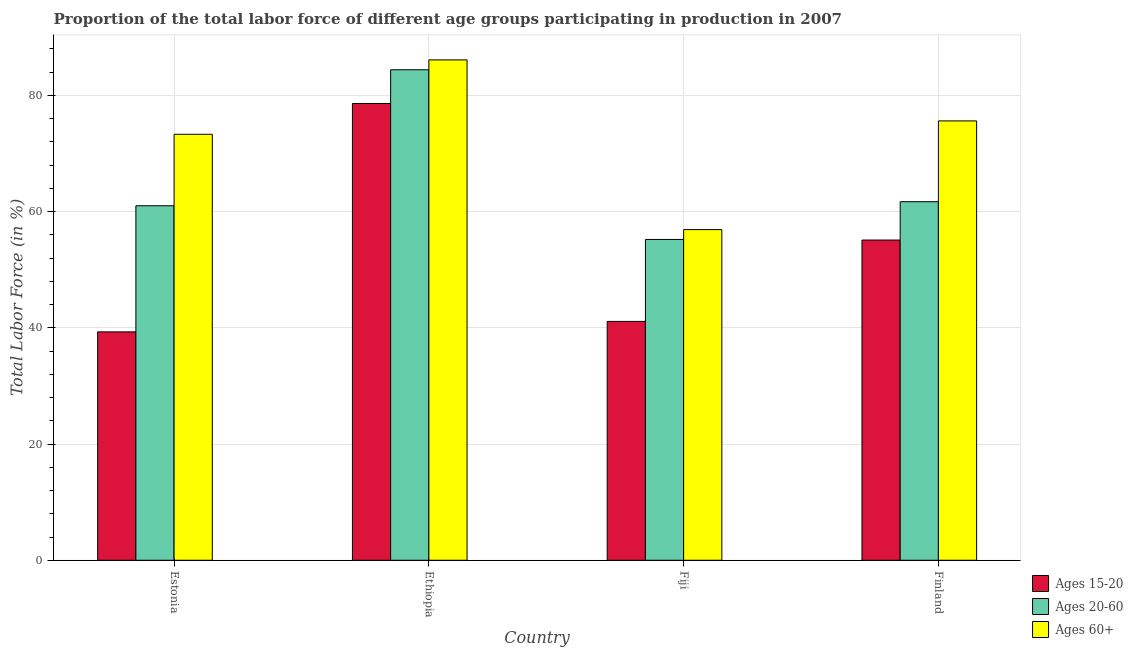How many different coloured bars are there?
Provide a succinct answer. 3. How many groups of bars are there?
Give a very brief answer. 4. Are the number of bars on each tick of the X-axis equal?
Give a very brief answer. Yes. How many bars are there on the 2nd tick from the left?
Provide a short and direct response. 3. What is the label of the 4th group of bars from the left?
Ensure brevity in your answer.  Finland. What is the percentage of labor force within the age group 20-60 in Finland?
Provide a succinct answer. 61.7. Across all countries, what is the maximum percentage of labor force within the age group 15-20?
Your answer should be very brief. 78.6. Across all countries, what is the minimum percentage of labor force above age 60?
Provide a short and direct response. 56.9. In which country was the percentage of labor force within the age group 15-20 maximum?
Provide a short and direct response. Ethiopia. In which country was the percentage of labor force within the age group 20-60 minimum?
Your answer should be very brief. Fiji. What is the total percentage of labor force within the age group 20-60 in the graph?
Your response must be concise. 262.3. What is the difference between the percentage of labor force within the age group 20-60 in Estonia and that in Finland?
Provide a succinct answer. -0.7. What is the difference between the percentage of labor force within the age group 15-20 in Fiji and the percentage of labor force within the age group 20-60 in Finland?
Your answer should be very brief. -20.6. What is the average percentage of labor force within the age group 20-60 per country?
Your response must be concise. 65.58. What is the difference between the percentage of labor force above age 60 and percentage of labor force within the age group 15-20 in Ethiopia?
Your response must be concise. 7.5. What is the ratio of the percentage of labor force within the age group 15-20 in Estonia to that in Ethiopia?
Your answer should be compact. 0.5. Is the percentage of labor force above age 60 in Ethiopia less than that in Finland?
Provide a short and direct response. No. Is the difference between the percentage of labor force within the age group 15-20 in Ethiopia and Finland greater than the difference between the percentage of labor force within the age group 20-60 in Ethiopia and Finland?
Your answer should be compact. Yes. What is the difference between the highest and the second highest percentage of labor force within the age group 20-60?
Ensure brevity in your answer.  22.7. What is the difference between the highest and the lowest percentage of labor force within the age group 20-60?
Your answer should be very brief. 29.2. In how many countries, is the percentage of labor force within the age group 20-60 greater than the average percentage of labor force within the age group 20-60 taken over all countries?
Keep it short and to the point. 1. Is the sum of the percentage of labor force within the age group 15-20 in Estonia and Finland greater than the maximum percentage of labor force above age 60 across all countries?
Offer a very short reply. Yes. What does the 1st bar from the left in Fiji represents?
Provide a short and direct response. Ages 15-20. What does the 2nd bar from the right in Fiji represents?
Your answer should be very brief. Ages 20-60. How many bars are there?
Ensure brevity in your answer.  12. What is the difference between two consecutive major ticks on the Y-axis?
Offer a very short reply. 20. Does the graph contain any zero values?
Keep it short and to the point. No. Where does the legend appear in the graph?
Provide a short and direct response. Bottom right. How many legend labels are there?
Offer a terse response. 3. What is the title of the graph?
Offer a very short reply. Proportion of the total labor force of different age groups participating in production in 2007. Does "Labor Tax" appear as one of the legend labels in the graph?
Offer a terse response. No. What is the label or title of the X-axis?
Provide a short and direct response. Country. What is the Total Labor Force (in %) in Ages 15-20 in Estonia?
Your answer should be very brief. 39.3. What is the Total Labor Force (in %) of Ages 20-60 in Estonia?
Provide a succinct answer. 61. What is the Total Labor Force (in %) of Ages 60+ in Estonia?
Offer a terse response. 73.3. What is the Total Labor Force (in %) in Ages 15-20 in Ethiopia?
Your response must be concise. 78.6. What is the Total Labor Force (in %) of Ages 20-60 in Ethiopia?
Offer a very short reply. 84.4. What is the Total Labor Force (in %) of Ages 60+ in Ethiopia?
Offer a terse response. 86.1. What is the Total Labor Force (in %) of Ages 15-20 in Fiji?
Provide a succinct answer. 41.1. What is the Total Labor Force (in %) in Ages 20-60 in Fiji?
Offer a terse response. 55.2. What is the Total Labor Force (in %) of Ages 60+ in Fiji?
Your answer should be compact. 56.9. What is the Total Labor Force (in %) in Ages 15-20 in Finland?
Ensure brevity in your answer.  55.1. What is the Total Labor Force (in %) in Ages 20-60 in Finland?
Make the answer very short. 61.7. What is the Total Labor Force (in %) of Ages 60+ in Finland?
Keep it short and to the point. 75.6. Across all countries, what is the maximum Total Labor Force (in %) of Ages 15-20?
Your answer should be very brief. 78.6. Across all countries, what is the maximum Total Labor Force (in %) in Ages 20-60?
Offer a very short reply. 84.4. Across all countries, what is the maximum Total Labor Force (in %) of Ages 60+?
Provide a succinct answer. 86.1. Across all countries, what is the minimum Total Labor Force (in %) in Ages 15-20?
Make the answer very short. 39.3. Across all countries, what is the minimum Total Labor Force (in %) in Ages 20-60?
Your answer should be compact. 55.2. Across all countries, what is the minimum Total Labor Force (in %) of Ages 60+?
Provide a short and direct response. 56.9. What is the total Total Labor Force (in %) of Ages 15-20 in the graph?
Provide a short and direct response. 214.1. What is the total Total Labor Force (in %) in Ages 20-60 in the graph?
Ensure brevity in your answer.  262.3. What is the total Total Labor Force (in %) of Ages 60+ in the graph?
Make the answer very short. 291.9. What is the difference between the Total Labor Force (in %) in Ages 15-20 in Estonia and that in Ethiopia?
Ensure brevity in your answer.  -39.3. What is the difference between the Total Labor Force (in %) in Ages 20-60 in Estonia and that in Ethiopia?
Your answer should be very brief. -23.4. What is the difference between the Total Labor Force (in %) in Ages 20-60 in Estonia and that in Fiji?
Give a very brief answer. 5.8. What is the difference between the Total Labor Force (in %) of Ages 60+ in Estonia and that in Fiji?
Offer a very short reply. 16.4. What is the difference between the Total Labor Force (in %) of Ages 15-20 in Estonia and that in Finland?
Provide a succinct answer. -15.8. What is the difference between the Total Labor Force (in %) in Ages 20-60 in Estonia and that in Finland?
Make the answer very short. -0.7. What is the difference between the Total Labor Force (in %) of Ages 60+ in Estonia and that in Finland?
Your answer should be compact. -2.3. What is the difference between the Total Labor Force (in %) of Ages 15-20 in Ethiopia and that in Fiji?
Provide a succinct answer. 37.5. What is the difference between the Total Labor Force (in %) in Ages 20-60 in Ethiopia and that in Fiji?
Ensure brevity in your answer.  29.2. What is the difference between the Total Labor Force (in %) of Ages 60+ in Ethiopia and that in Fiji?
Your answer should be compact. 29.2. What is the difference between the Total Labor Force (in %) in Ages 15-20 in Ethiopia and that in Finland?
Offer a terse response. 23.5. What is the difference between the Total Labor Force (in %) in Ages 20-60 in Ethiopia and that in Finland?
Provide a succinct answer. 22.7. What is the difference between the Total Labor Force (in %) in Ages 60+ in Ethiopia and that in Finland?
Your answer should be very brief. 10.5. What is the difference between the Total Labor Force (in %) of Ages 60+ in Fiji and that in Finland?
Ensure brevity in your answer.  -18.7. What is the difference between the Total Labor Force (in %) in Ages 15-20 in Estonia and the Total Labor Force (in %) in Ages 20-60 in Ethiopia?
Your answer should be very brief. -45.1. What is the difference between the Total Labor Force (in %) in Ages 15-20 in Estonia and the Total Labor Force (in %) in Ages 60+ in Ethiopia?
Your answer should be very brief. -46.8. What is the difference between the Total Labor Force (in %) of Ages 20-60 in Estonia and the Total Labor Force (in %) of Ages 60+ in Ethiopia?
Give a very brief answer. -25.1. What is the difference between the Total Labor Force (in %) in Ages 15-20 in Estonia and the Total Labor Force (in %) in Ages 20-60 in Fiji?
Ensure brevity in your answer.  -15.9. What is the difference between the Total Labor Force (in %) in Ages 15-20 in Estonia and the Total Labor Force (in %) in Ages 60+ in Fiji?
Offer a terse response. -17.6. What is the difference between the Total Labor Force (in %) in Ages 20-60 in Estonia and the Total Labor Force (in %) in Ages 60+ in Fiji?
Keep it short and to the point. 4.1. What is the difference between the Total Labor Force (in %) in Ages 15-20 in Estonia and the Total Labor Force (in %) in Ages 20-60 in Finland?
Provide a succinct answer. -22.4. What is the difference between the Total Labor Force (in %) of Ages 15-20 in Estonia and the Total Labor Force (in %) of Ages 60+ in Finland?
Offer a very short reply. -36.3. What is the difference between the Total Labor Force (in %) of Ages 20-60 in Estonia and the Total Labor Force (in %) of Ages 60+ in Finland?
Provide a succinct answer. -14.6. What is the difference between the Total Labor Force (in %) in Ages 15-20 in Ethiopia and the Total Labor Force (in %) in Ages 20-60 in Fiji?
Offer a terse response. 23.4. What is the difference between the Total Labor Force (in %) in Ages 15-20 in Ethiopia and the Total Labor Force (in %) in Ages 60+ in Fiji?
Give a very brief answer. 21.7. What is the difference between the Total Labor Force (in %) of Ages 15-20 in Ethiopia and the Total Labor Force (in %) of Ages 60+ in Finland?
Keep it short and to the point. 3. What is the difference between the Total Labor Force (in %) of Ages 20-60 in Ethiopia and the Total Labor Force (in %) of Ages 60+ in Finland?
Offer a very short reply. 8.8. What is the difference between the Total Labor Force (in %) of Ages 15-20 in Fiji and the Total Labor Force (in %) of Ages 20-60 in Finland?
Provide a short and direct response. -20.6. What is the difference between the Total Labor Force (in %) in Ages 15-20 in Fiji and the Total Labor Force (in %) in Ages 60+ in Finland?
Offer a terse response. -34.5. What is the difference between the Total Labor Force (in %) in Ages 20-60 in Fiji and the Total Labor Force (in %) in Ages 60+ in Finland?
Offer a terse response. -20.4. What is the average Total Labor Force (in %) in Ages 15-20 per country?
Provide a short and direct response. 53.52. What is the average Total Labor Force (in %) of Ages 20-60 per country?
Offer a terse response. 65.58. What is the average Total Labor Force (in %) in Ages 60+ per country?
Provide a short and direct response. 72.97. What is the difference between the Total Labor Force (in %) in Ages 15-20 and Total Labor Force (in %) in Ages 20-60 in Estonia?
Ensure brevity in your answer.  -21.7. What is the difference between the Total Labor Force (in %) in Ages 15-20 and Total Labor Force (in %) in Ages 60+ in Estonia?
Your answer should be compact. -34. What is the difference between the Total Labor Force (in %) of Ages 20-60 and Total Labor Force (in %) of Ages 60+ in Estonia?
Your answer should be compact. -12.3. What is the difference between the Total Labor Force (in %) in Ages 15-20 and Total Labor Force (in %) in Ages 60+ in Ethiopia?
Keep it short and to the point. -7.5. What is the difference between the Total Labor Force (in %) of Ages 15-20 and Total Labor Force (in %) of Ages 20-60 in Fiji?
Make the answer very short. -14.1. What is the difference between the Total Labor Force (in %) in Ages 15-20 and Total Labor Force (in %) in Ages 60+ in Fiji?
Your answer should be very brief. -15.8. What is the difference between the Total Labor Force (in %) in Ages 20-60 and Total Labor Force (in %) in Ages 60+ in Fiji?
Offer a terse response. -1.7. What is the difference between the Total Labor Force (in %) of Ages 15-20 and Total Labor Force (in %) of Ages 20-60 in Finland?
Make the answer very short. -6.6. What is the difference between the Total Labor Force (in %) in Ages 15-20 and Total Labor Force (in %) in Ages 60+ in Finland?
Offer a terse response. -20.5. What is the difference between the Total Labor Force (in %) of Ages 20-60 and Total Labor Force (in %) of Ages 60+ in Finland?
Provide a succinct answer. -13.9. What is the ratio of the Total Labor Force (in %) of Ages 20-60 in Estonia to that in Ethiopia?
Make the answer very short. 0.72. What is the ratio of the Total Labor Force (in %) in Ages 60+ in Estonia to that in Ethiopia?
Your answer should be compact. 0.85. What is the ratio of the Total Labor Force (in %) of Ages 15-20 in Estonia to that in Fiji?
Provide a short and direct response. 0.96. What is the ratio of the Total Labor Force (in %) of Ages 20-60 in Estonia to that in Fiji?
Provide a short and direct response. 1.11. What is the ratio of the Total Labor Force (in %) of Ages 60+ in Estonia to that in Fiji?
Give a very brief answer. 1.29. What is the ratio of the Total Labor Force (in %) of Ages 15-20 in Estonia to that in Finland?
Ensure brevity in your answer.  0.71. What is the ratio of the Total Labor Force (in %) of Ages 20-60 in Estonia to that in Finland?
Provide a short and direct response. 0.99. What is the ratio of the Total Labor Force (in %) in Ages 60+ in Estonia to that in Finland?
Your answer should be very brief. 0.97. What is the ratio of the Total Labor Force (in %) in Ages 15-20 in Ethiopia to that in Fiji?
Your response must be concise. 1.91. What is the ratio of the Total Labor Force (in %) of Ages 20-60 in Ethiopia to that in Fiji?
Make the answer very short. 1.53. What is the ratio of the Total Labor Force (in %) of Ages 60+ in Ethiopia to that in Fiji?
Ensure brevity in your answer.  1.51. What is the ratio of the Total Labor Force (in %) in Ages 15-20 in Ethiopia to that in Finland?
Offer a terse response. 1.43. What is the ratio of the Total Labor Force (in %) in Ages 20-60 in Ethiopia to that in Finland?
Offer a terse response. 1.37. What is the ratio of the Total Labor Force (in %) in Ages 60+ in Ethiopia to that in Finland?
Provide a short and direct response. 1.14. What is the ratio of the Total Labor Force (in %) in Ages 15-20 in Fiji to that in Finland?
Your answer should be compact. 0.75. What is the ratio of the Total Labor Force (in %) in Ages 20-60 in Fiji to that in Finland?
Ensure brevity in your answer.  0.89. What is the ratio of the Total Labor Force (in %) of Ages 60+ in Fiji to that in Finland?
Give a very brief answer. 0.75. What is the difference between the highest and the second highest Total Labor Force (in %) of Ages 20-60?
Offer a very short reply. 22.7. What is the difference between the highest and the lowest Total Labor Force (in %) of Ages 15-20?
Your response must be concise. 39.3. What is the difference between the highest and the lowest Total Labor Force (in %) of Ages 20-60?
Ensure brevity in your answer.  29.2. What is the difference between the highest and the lowest Total Labor Force (in %) in Ages 60+?
Give a very brief answer. 29.2. 